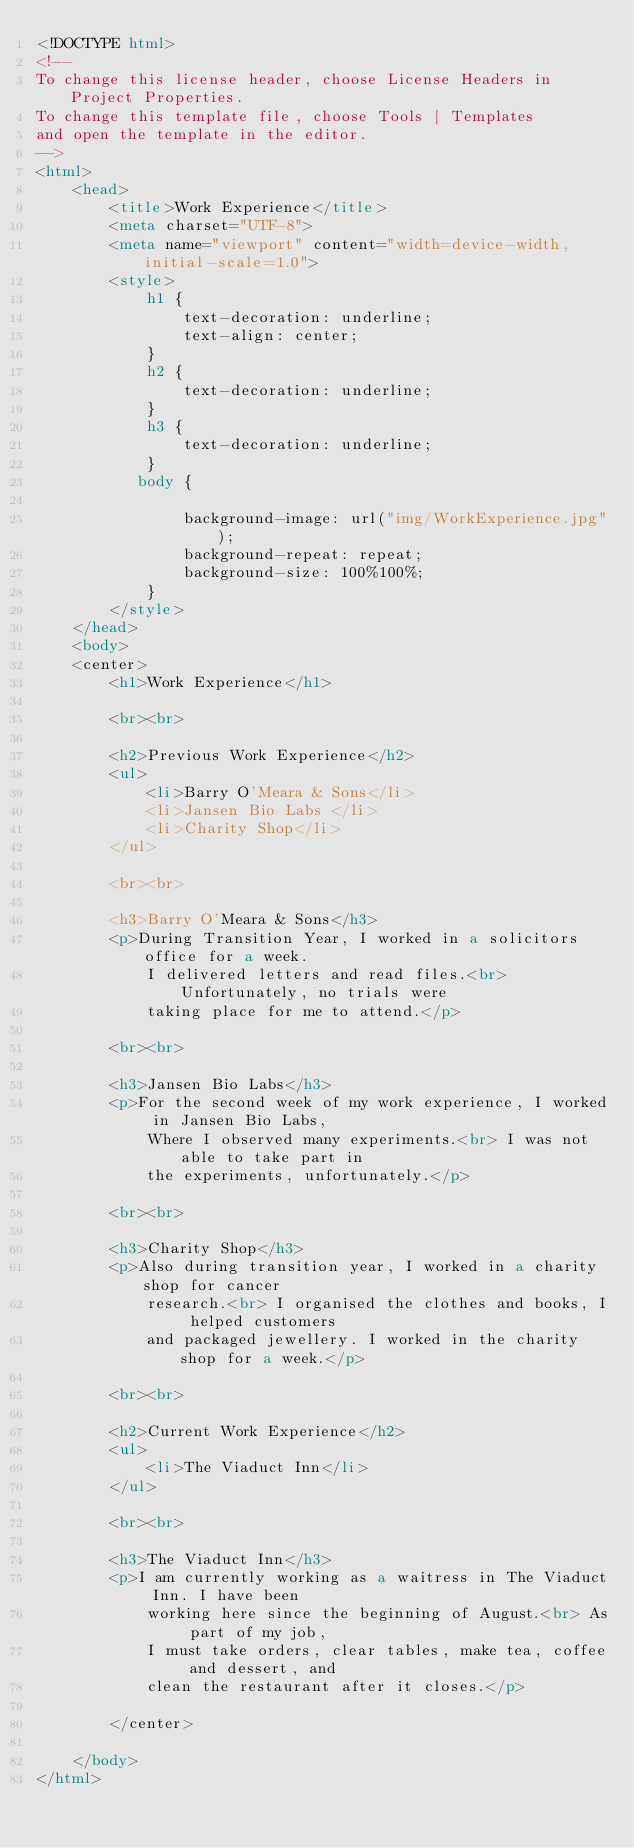Convert code to text. <code><loc_0><loc_0><loc_500><loc_500><_HTML_><!DOCTYPE html>
<!--
To change this license header, choose License Headers in Project Properties.
To change this template file, choose Tools | Templates
and open the template in the editor.
-->
<html>
    <head>
        <title>Work Experience</title>
        <meta charset="UTF-8">
        <meta name="viewport" content="width=device-width, initial-scale=1.0">
        <style>
            h1 {
                text-decoration: underline;
                text-align: center; 
            }
            h2 {
                text-decoration: underline;
            }
            h3 {
                text-decoration: underline;
            }
           body {
              
                background-image: url("img/WorkExperience.jpg");
                background-repeat: repeat;
                background-size: 100%100%;
            }
        </style>
    </head>
    <body>
    <center>        
        <h1>Work Experience</h1>
        
        <br><br>
        
        <h2>Previous Work Experience</h2>
        <ul>
            <li>Barry O'Meara & Sons</li>
            <li>Jansen Bio Labs </li>
            <li>Charity Shop</li>
        </ul>
        
        <br><br>
        
        <h3>Barry O'Meara & Sons</h3>
        <p>During Transition Year, I worked in a solicitors office for a week.
            I delivered letters and read files.<br> Unfortunately, no trials were
            taking place for me to attend.</p>
        
        <br><br>
        
        <h3>Jansen Bio Labs</h3>
        <p>For the second week of my work experience, I worked in Jansen Bio Labs,
            Where I observed many experiments.<br> I was not able to take part in 
            the experiments, unfortunately.</p>
        
        <br><br>
        
        <h3>Charity Shop</h3>
        <p>Also during transition year, I worked in a charity shop for cancer 
            research.<br> I organised the clothes and books, I helped customers
            and packaged jewellery. I worked in the charity shop for a week.</p>
        
        <br><br>
        
        <h2>Current Work Experience</h2>
        <ul>
            <li>The Viaduct Inn</li>
        </ul>
        
        <br><br>
        
        <h3>The Viaduct Inn</h3>
        <p>I am currently working as a waitress in The Viaduct Inn. I have been 
            working here since the beginning of August.<br> As part of my job,
            I must take orders, clear tables, make tea, coffee and dessert, and
            clean the restaurant after it closes.</p>
        
        </center>
            
    </body>
</html>
</code> 